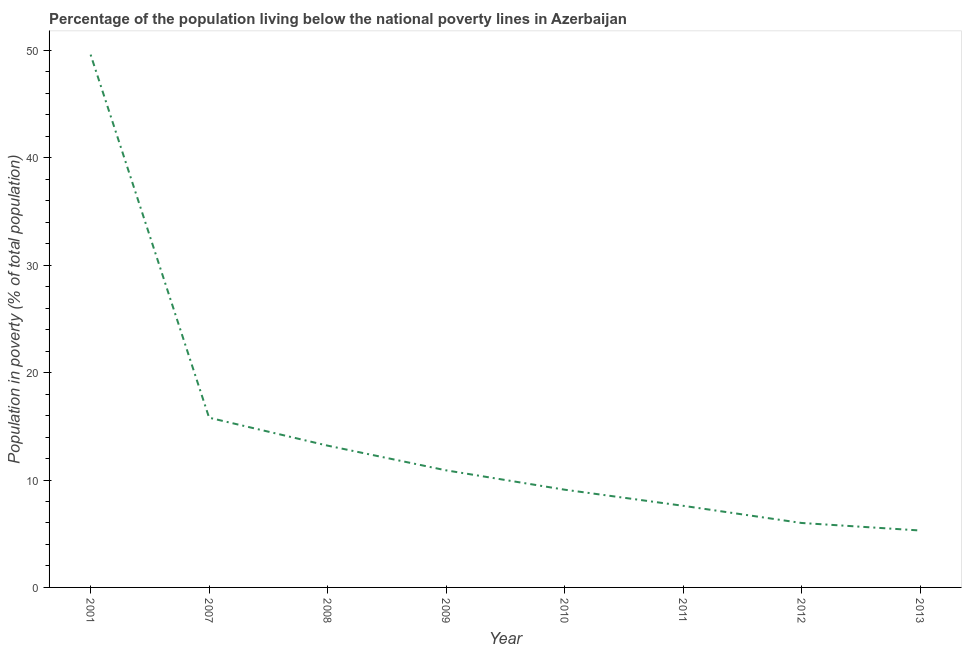Across all years, what is the maximum percentage of population living below poverty line?
Your answer should be compact. 49.6. Across all years, what is the minimum percentage of population living below poverty line?
Offer a very short reply. 5.3. In which year was the percentage of population living below poverty line maximum?
Ensure brevity in your answer.  2001. In which year was the percentage of population living below poverty line minimum?
Your response must be concise. 2013. What is the sum of the percentage of population living below poverty line?
Offer a terse response. 117.5. What is the difference between the percentage of population living below poverty line in 2001 and 2009?
Provide a succinct answer. 38.7. What is the average percentage of population living below poverty line per year?
Give a very brief answer. 14.69. What is the median percentage of population living below poverty line?
Provide a short and direct response. 10. In how many years, is the percentage of population living below poverty line greater than 26 %?
Give a very brief answer. 1. Do a majority of the years between 2011 and 2012 (inclusive) have percentage of population living below poverty line greater than 36 %?
Give a very brief answer. No. What is the ratio of the percentage of population living below poverty line in 2001 to that in 2011?
Ensure brevity in your answer.  6.53. Is the difference between the percentage of population living below poverty line in 2010 and 2013 greater than the difference between any two years?
Keep it short and to the point. No. What is the difference between the highest and the second highest percentage of population living below poverty line?
Offer a very short reply. 33.8. Is the sum of the percentage of population living below poverty line in 2007 and 2009 greater than the maximum percentage of population living below poverty line across all years?
Your answer should be very brief. No. What is the difference between the highest and the lowest percentage of population living below poverty line?
Offer a terse response. 44.3. In how many years, is the percentage of population living below poverty line greater than the average percentage of population living below poverty line taken over all years?
Provide a succinct answer. 2. Does the percentage of population living below poverty line monotonically increase over the years?
Provide a succinct answer. No. Are the values on the major ticks of Y-axis written in scientific E-notation?
Give a very brief answer. No. Does the graph contain grids?
Offer a terse response. No. What is the title of the graph?
Your response must be concise. Percentage of the population living below the national poverty lines in Azerbaijan. What is the label or title of the X-axis?
Provide a short and direct response. Year. What is the label or title of the Y-axis?
Offer a terse response. Population in poverty (% of total population). What is the Population in poverty (% of total population) of 2001?
Offer a terse response. 49.6. What is the Population in poverty (% of total population) of 2007?
Your answer should be compact. 15.8. What is the Population in poverty (% of total population) of 2008?
Offer a very short reply. 13.2. What is the Population in poverty (% of total population) in 2009?
Give a very brief answer. 10.9. What is the Population in poverty (% of total population) of 2011?
Offer a terse response. 7.6. What is the difference between the Population in poverty (% of total population) in 2001 and 2007?
Provide a succinct answer. 33.8. What is the difference between the Population in poverty (% of total population) in 2001 and 2008?
Give a very brief answer. 36.4. What is the difference between the Population in poverty (% of total population) in 2001 and 2009?
Provide a short and direct response. 38.7. What is the difference between the Population in poverty (% of total population) in 2001 and 2010?
Keep it short and to the point. 40.5. What is the difference between the Population in poverty (% of total population) in 2001 and 2012?
Provide a short and direct response. 43.6. What is the difference between the Population in poverty (% of total population) in 2001 and 2013?
Offer a terse response. 44.3. What is the difference between the Population in poverty (% of total population) in 2007 and 2008?
Your response must be concise. 2.6. What is the difference between the Population in poverty (% of total population) in 2007 and 2009?
Keep it short and to the point. 4.9. What is the difference between the Population in poverty (% of total population) in 2007 and 2010?
Your answer should be very brief. 6.7. What is the difference between the Population in poverty (% of total population) in 2007 and 2013?
Your response must be concise. 10.5. What is the difference between the Population in poverty (% of total population) in 2008 and 2009?
Your answer should be very brief. 2.3. What is the difference between the Population in poverty (% of total population) in 2008 and 2012?
Offer a terse response. 7.2. What is the difference between the Population in poverty (% of total population) in 2009 and 2013?
Give a very brief answer. 5.6. What is the difference between the Population in poverty (% of total population) in 2010 and 2013?
Provide a succinct answer. 3.8. What is the difference between the Population in poverty (% of total population) in 2011 and 2012?
Offer a terse response. 1.6. What is the ratio of the Population in poverty (% of total population) in 2001 to that in 2007?
Your response must be concise. 3.14. What is the ratio of the Population in poverty (% of total population) in 2001 to that in 2008?
Your response must be concise. 3.76. What is the ratio of the Population in poverty (% of total population) in 2001 to that in 2009?
Make the answer very short. 4.55. What is the ratio of the Population in poverty (% of total population) in 2001 to that in 2010?
Give a very brief answer. 5.45. What is the ratio of the Population in poverty (% of total population) in 2001 to that in 2011?
Make the answer very short. 6.53. What is the ratio of the Population in poverty (% of total population) in 2001 to that in 2012?
Your response must be concise. 8.27. What is the ratio of the Population in poverty (% of total population) in 2001 to that in 2013?
Offer a very short reply. 9.36. What is the ratio of the Population in poverty (% of total population) in 2007 to that in 2008?
Provide a short and direct response. 1.2. What is the ratio of the Population in poverty (% of total population) in 2007 to that in 2009?
Give a very brief answer. 1.45. What is the ratio of the Population in poverty (% of total population) in 2007 to that in 2010?
Make the answer very short. 1.74. What is the ratio of the Population in poverty (% of total population) in 2007 to that in 2011?
Give a very brief answer. 2.08. What is the ratio of the Population in poverty (% of total population) in 2007 to that in 2012?
Make the answer very short. 2.63. What is the ratio of the Population in poverty (% of total population) in 2007 to that in 2013?
Your response must be concise. 2.98. What is the ratio of the Population in poverty (% of total population) in 2008 to that in 2009?
Give a very brief answer. 1.21. What is the ratio of the Population in poverty (% of total population) in 2008 to that in 2010?
Provide a succinct answer. 1.45. What is the ratio of the Population in poverty (% of total population) in 2008 to that in 2011?
Give a very brief answer. 1.74. What is the ratio of the Population in poverty (% of total population) in 2008 to that in 2012?
Offer a terse response. 2.2. What is the ratio of the Population in poverty (% of total population) in 2008 to that in 2013?
Your answer should be compact. 2.49. What is the ratio of the Population in poverty (% of total population) in 2009 to that in 2010?
Offer a terse response. 1.2. What is the ratio of the Population in poverty (% of total population) in 2009 to that in 2011?
Offer a terse response. 1.43. What is the ratio of the Population in poverty (% of total population) in 2009 to that in 2012?
Provide a succinct answer. 1.82. What is the ratio of the Population in poverty (% of total population) in 2009 to that in 2013?
Your answer should be very brief. 2.06. What is the ratio of the Population in poverty (% of total population) in 2010 to that in 2011?
Offer a very short reply. 1.2. What is the ratio of the Population in poverty (% of total population) in 2010 to that in 2012?
Offer a terse response. 1.52. What is the ratio of the Population in poverty (% of total population) in 2010 to that in 2013?
Your answer should be compact. 1.72. What is the ratio of the Population in poverty (% of total population) in 2011 to that in 2012?
Ensure brevity in your answer.  1.27. What is the ratio of the Population in poverty (% of total population) in 2011 to that in 2013?
Make the answer very short. 1.43. What is the ratio of the Population in poverty (% of total population) in 2012 to that in 2013?
Keep it short and to the point. 1.13. 